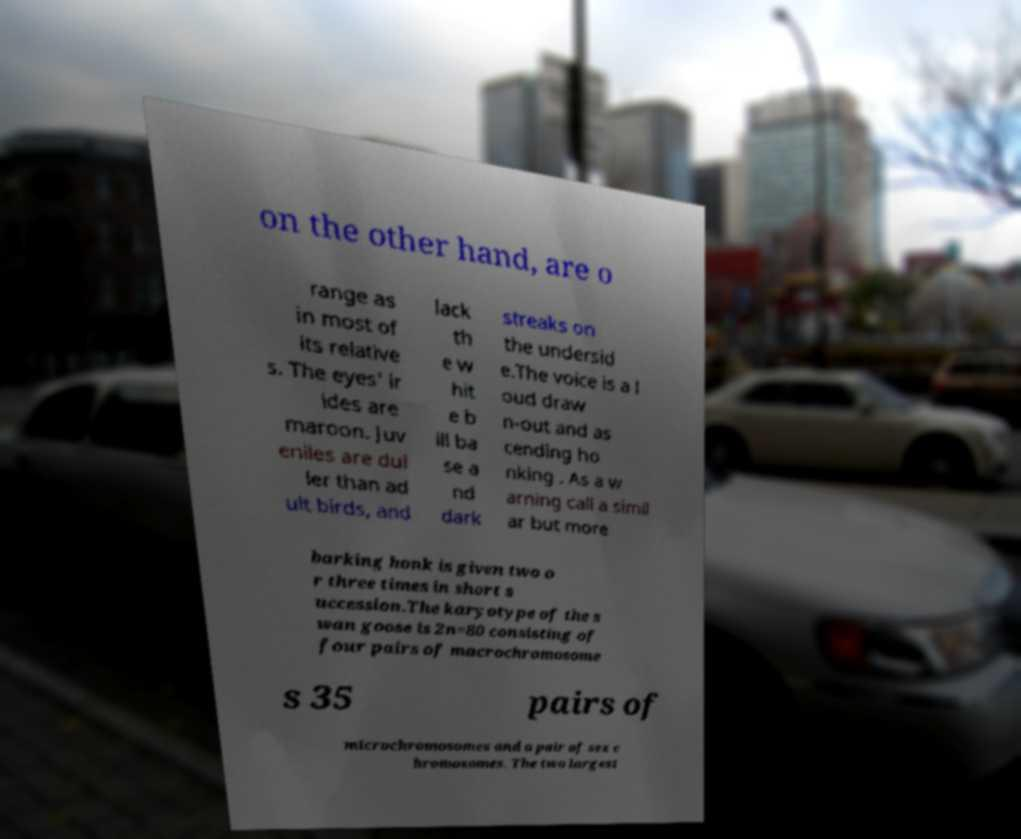What messages or text are displayed in this image? I need them in a readable, typed format. on the other hand, are o range as in most of its relative s. The eyes' ir ides are maroon. Juv eniles are dul ler than ad ult birds, and lack th e w hit e b ill ba se a nd dark streaks on the undersid e.The voice is a l oud draw n-out and as cending ho nking . As a w arning call a simil ar but more barking honk is given two o r three times in short s uccession.The karyotype of the s wan goose is 2n=80 consisting of four pairs of macrochromosome s 35 pairs of microchromosomes and a pair of sex c hromosomes. The two largest 